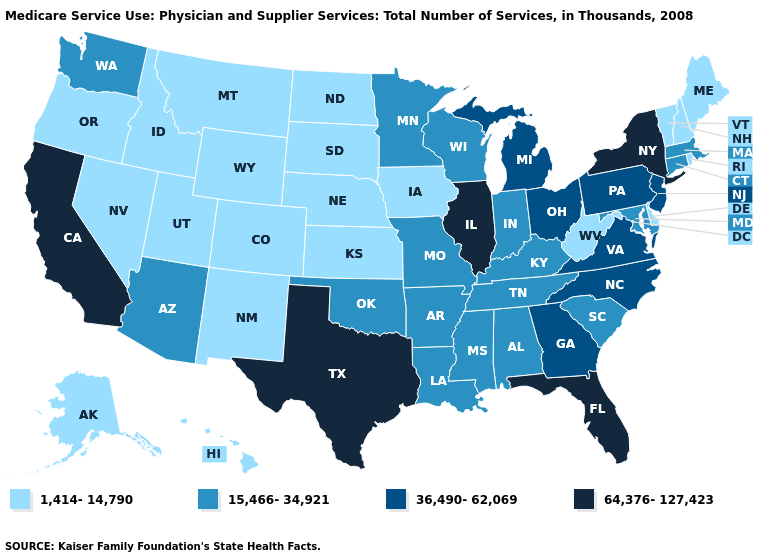Does Pennsylvania have the same value as Virginia?
Short answer required. Yes. How many symbols are there in the legend?
Quick response, please. 4. Does New York have the highest value in the Northeast?
Quick response, please. Yes. Does Michigan have the same value as Missouri?
Give a very brief answer. No. Is the legend a continuous bar?
Answer briefly. No. What is the value of Minnesota?
Write a very short answer. 15,466-34,921. Among the states that border Oregon , does California have the highest value?
Write a very short answer. Yes. What is the highest value in states that border Oklahoma?
Concise answer only. 64,376-127,423. Which states have the lowest value in the USA?
Give a very brief answer. Alaska, Colorado, Delaware, Hawaii, Idaho, Iowa, Kansas, Maine, Montana, Nebraska, Nevada, New Hampshire, New Mexico, North Dakota, Oregon, Rhode Island, South Dakota, Utah, Vermont, West Virginia, Wyoming. Does New York have the lowest value in the USA?
Short answer required. No. What is the lowest value in the South?
Concise answer only. 1,414-14,790. What is the value of Connecticut?
Be succinct. 15,466-34,921. Does the first symbol in the legend represent the smallest category?
Concise answer only. Yes. Name the states that have a value in the range 64,376-127,423?
Answer briefly. California, Florida, Illinois, New York, Texas. Does Illinois have the highest value in the MidWest?
Quick response, please. Yes. 